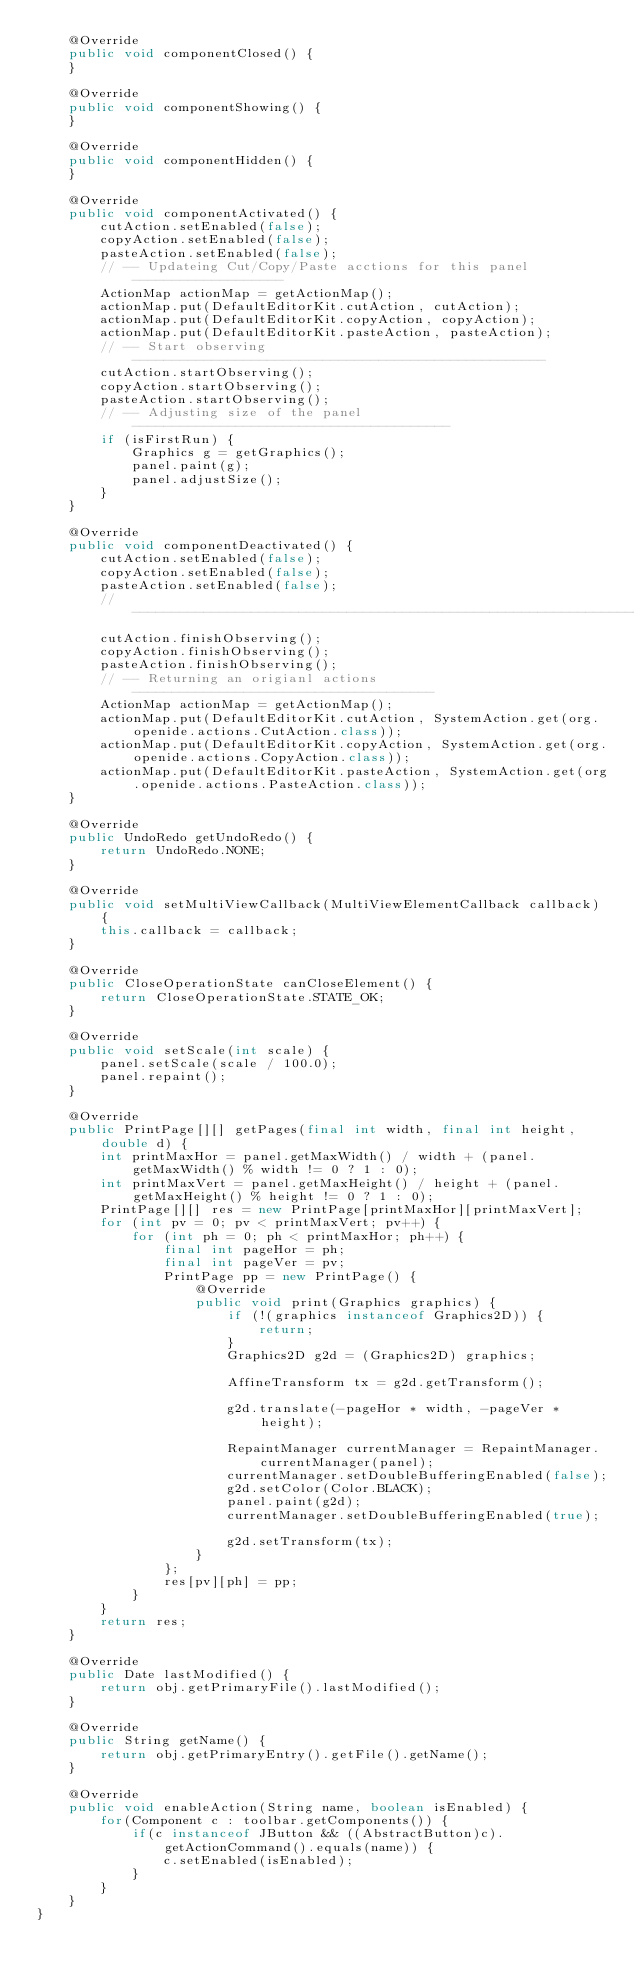Convert code to text. <code><loc_0><loc_0><loc_500><loc_500><_Java_>    @Override
    public void componentClosed() {
    }

    @Override
    public void componentShowing() {
    }

    @Override
    public void componentHidden() {
    }

    @Override
    public void componentActivated() {
        cutAction.setEnabled(false);
        copyAction.setEnabled(false);
        pasteAction.setEnabled(false);
        // -- Updateing Cut/Copy/Paste acctions for this panel -------------------
        ActionMap actionMap = getActionMap();
        actionMap.put(DefaultEditorKit.cutAction, cutAction);
        actionMap.put(DefaultEditorKit.copyAction, copyAction);
        actionMap.put(DefaultEditorKit.pasteAction, pasteAction);
        // -- Start observing ----------------------------------------------------
        cutAction.startObserving();
        copyAction.startObserving();
        pasteAction.startObserving();
        // -- Adjusting size of the panel ----------------------------------------
        if (isFirstRun) {
            Graphics g = getGraphics();
            panel.paint(g);
            panel.adjustSize();
        }
    }

    @Override
    public void componentDeactivated() {
        cutAction.setEnabled(false);
        copyAction.setEnabled(false);
        pasteAction.setEnabled(false);
        // -----------------------------------------------------------------------
        cutAction.finishObserving();
        copyAction.finishObserving();
        pasteAction.finishObserving();
        // -- Returning an origianl actions --------------------------------------
        ActionMap actionMap = getActionMap();
        actionMap.put(DefaultEditorKit.cutAction, SystemAction.get(org.openide.actions.CutAction.class));
        actionMap.put(DefaultEditorKit.copyAction, SystemAction.get(org.openide.actions.CopyAction.class));
        actionMap.put(DefaultEditorKit.pasteAction, SystemAction.get(org.openide.actions.PasteAction.class));
    }

    @Override
    public UndoRedo getUndoRedo() {
        return UndoRedo.NONE;
    }

    @Override
    public void setMultiViewCallback(MultiViewElementCallback callback) {
        this.callback = callback;
    }

    @Override
    public CloseOperationState canCloseElement() {
        return CloseOperationState.STATE_OK;
    }

    @Override
    public void setScale(int scale) {
        panel.setScale(scale / 100.0);
        panel.repaint();
    }

    @Override
    public PrintPage[][] getPages(final int width, final int height, double d) {
        int printMaxHor = panel.getMaxWidth() / width + (panel.getMaxWidth() % width != 0 ? 1 : 0);
        int printMaxVert = panel.getMaxHeight() / height + (panel.getMaxHeight() % height != 0 ? 1 : 0);
        PrintPage[][] res = new PrintPage[printMaxHor][printMaxVert];
        for (int pv = 0; pv < printMaxVert; pv++) {
            for (int ph = 0; ph < printMaxHor; ph++) {
                final int pageHor = ph;
                final int pageVer = pv;
                PrintPage pp = new PrintPage() {
                    @Override
                    public void print(Graphics graphics) {
                        if (!(graphics instanceof Graphics2D)) {
                            return;
                        }
                        Graphics2D g2d = (Graphics2D) graphics;

                        AffineTransform tx = g2d.getTransform();

                        g2d.translate(-pageHor * width, -pageVer * height);

                        RepaintManager currentManager = RepaintManager.currentManager(panel);
                        currentManager.setDoubleBufferingEnabled(false);
                        g2d.setColor(Color.BLACK);
                        panel.paint(g2d);
                        currentManager.setDoubleBufferingEnabled(true);

                        g2d.setTransform(tx);
                    }
                };
                res[pv][ph] = pp;
            }
        }
        return res;
    }

    @Override
    public Date lastModified() {
        return obj.getPrimaryFile().lastModified();
    }

    @Override
    public String getName() {
        return obj.getPrimaryEntry().getFile().getName();
    }

    @Override
    public void enableAction(String name, boolean isEnabled) {
        for(Component c : toolbar.getComponents()) {
            if(c instanceof JButton && ((AbstractButton)c).getActionCommand().equals(name)) {
                c.setEnabled(isEnabled);
            }
        }
    }
}
</code> 